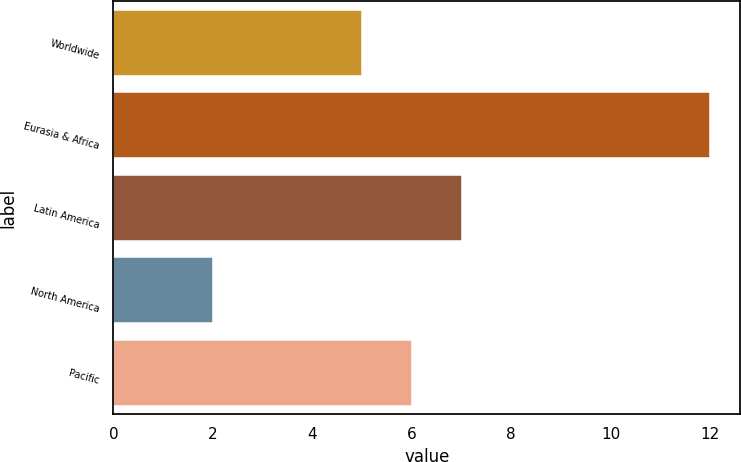<chart> <loc_0><loc_0><loc_500><loc_500><bar_chart><fcel>Worldwide<fcel>Eurasia & Africa<fcel>Latin America<fcel>North America<fcel>Pacific<nl><fcel>5<fcel>12<fcel>7<fcel>2<fcel>6<nl></chart> 